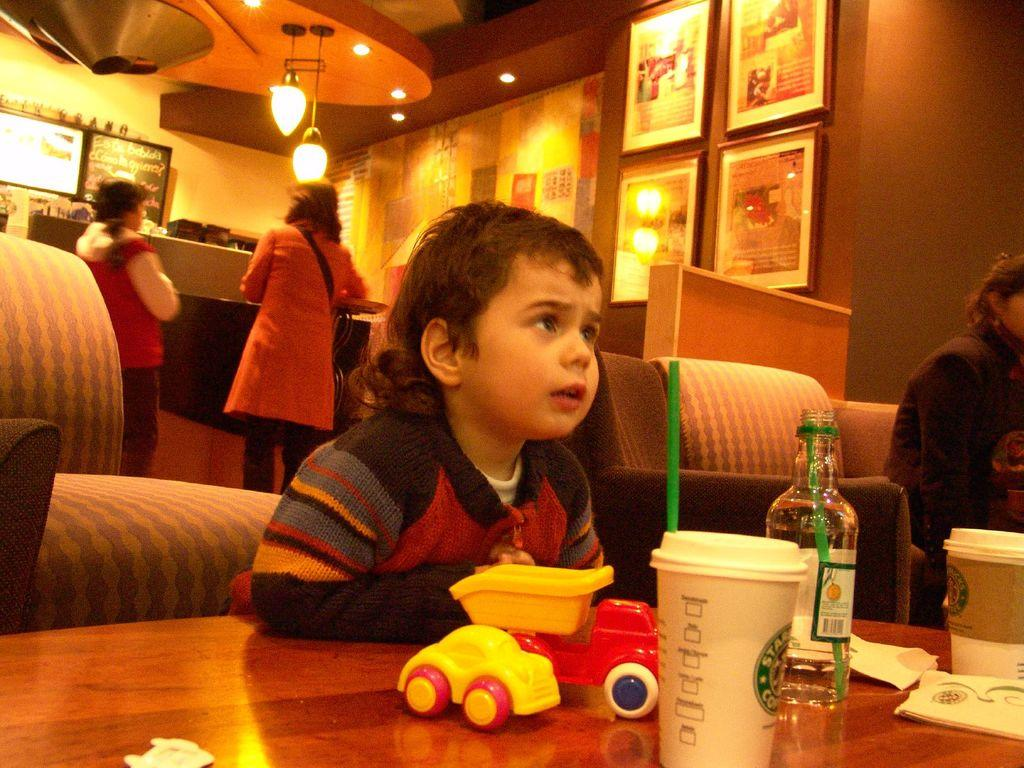How many people are in the room? There are people in the room, but the exact number is not specified. What objects can be found on the table? There are toys, a cup, and a bottle on the table. What is hanging from the roof? A light is hanging from the roof. What can be seen on the wall? There are frames on the wall. What is the level of the alarm in the room? There is no mention of an alarm in the image, so it is not possible to determine its level. 